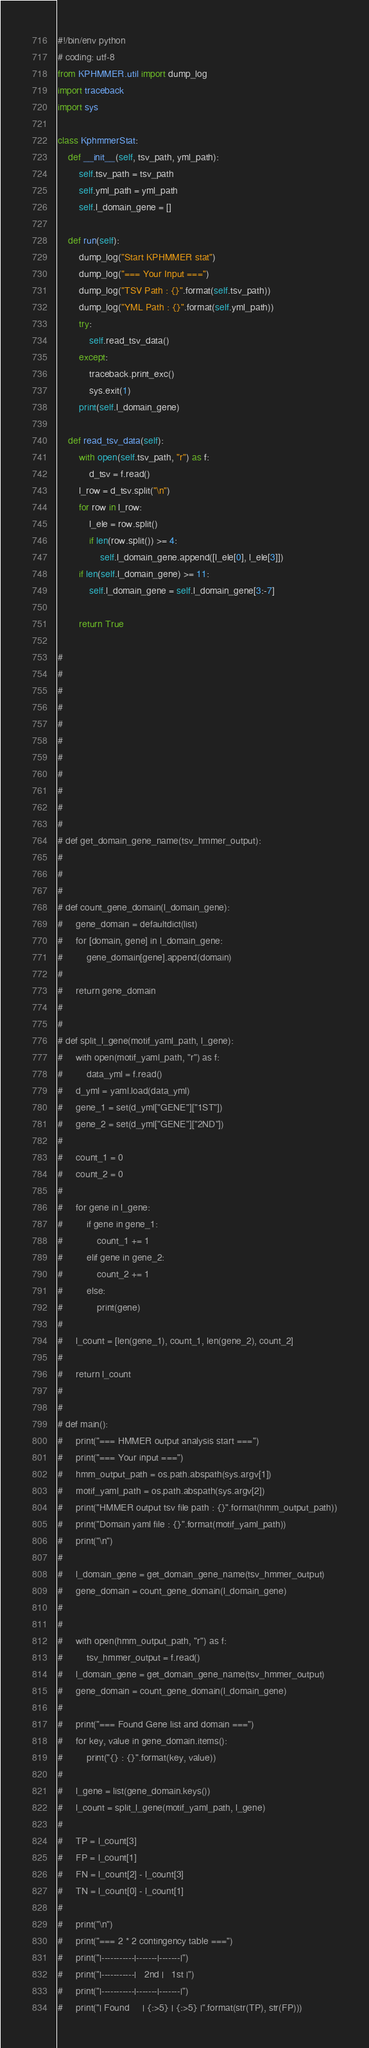Convert code to text. <code><loc_0><loc_0><loc_500><loc_500><_Python_>#!/bin/env python
# coding: utf-8
from KPHMMER.util import dump_log
import traceback
import sys

class KphmmerStat:
    def __init__(self, tsv_path, yml_path):
        self.tsv_path = tsv_path
        self.yml_path = yml_path
        self.l_domain_gene = []

    def run(self):
        dump_log("Start KPHMMER stat")
        dump_log("=== Your Input ===")
        dump_log("TSV Path : {}".format(self.tsv_path))
        dump_log("YML Path : {}".format(self.yml_path))
        try:
            self.read_tsv_data()
        except:
            traceback.print_exc()
            sys.exit(1)
        print(self.l_domain_gene)

    def read_tsv_data(self):
        with open(self.tsv_path, "r") as f:
            d_tsv = f.read()
        l_row = d_tsv.split("\n")
        for row in l_row:
            l_ele = row.split()
            if len(row.split()) >= 4:
                self.l_domain_gene.append([l_ele[0], l_ele[3]])
        if len(self.l_domain_gene) >= 11:
            self.l_domain_gene = self.l_domain_gene[3:-7]

        return True

#
#
#
#
#
#
#
#
#
#
#
# def get_domain_gene_name(tsv_hmmer_output):
#
#
#
# def count_gene_domain(l_domain_gene):
#     gene_domain = defaultdict(list)
#     for [domain, gene] in l_domain_gene:
#         gene_domain[gene].append(domain)
#
#     return gene_domain
#
#
# def split_l_gene(motif_yaml_path, l_gene):
#     with open(motif_yaml_path, "r") as f:
#         data_yml = f.read()
#     d_yml = yaml.load(data_yml)
#     gene_1 = set(d_yml["GENE"]["1ST"])
#     gene_2 = set(d_yml["GENE"]["2ND"])
#
#     count_1 = 0
#     count_2 = 0
#
#     for gene in l_gene:
#         if gene in gene_1:
#             count_1 += 1
#         elif gene in gene_2:
#             count_2 += 1
#         else:
#             print(gene)
#
#     l_count = [len(gene_1), count_1, len(gene_2), count_2]
#
#     return l_count
#
#
# def main():
#     print("=== HMMER output analysis start ===")
#     print("=== Your input ===")
#     hmm_output_path = os.path.abspath(sys.argv[1])
#     motif_yaml_path = os.path.abspath(sys.argv[2])
#     print("HMMER output tsv file path : {}".format(hmm_output_path))
#     print("Domain yaml file : {}".format(motif_yaml_path))
#     print("\n")
#
#     l_domain_gene = get_domain_gene_name(tsv_hmmer_output)
#     gene_domain = count_gene_domain(l_domain_gene)
#
#
#     with open(hmm_output_path, "r") as f:
#         tsv_hmmer_output = f.read()
#     l_domain_gene = get_domain_gene_name(tsv_hmmer_output)
#     gene_domain = count_gene_domain(l_domain_gene)
#
#     print("=== Found Gene list and domain ===")
#     for key, value in gene_domain.items():
#         print("{} : {}".format(key, value))
#
#     l_gene = list(gene_domain.keys())
#     l_count = split_l_gene(motif_yaml_path, l_gene)
#
#     TP = l_count[3]
#     FP = l_count[1]
#     FN = l_count[2] - l_count[3]
#     TN = l_count[0] - l_count[1]
#
#     print("\n")
#     print("=== 2 * 2 contingency table ===")
#     print("|-----------|-------|-------|")
#     print("|-----------|   2nd |   1st |")
#     print("|-----------|-------|-------|")
#     print("| Found     | {:>5} | {:>5} |".format(str(TP), str(FP)))</code> 